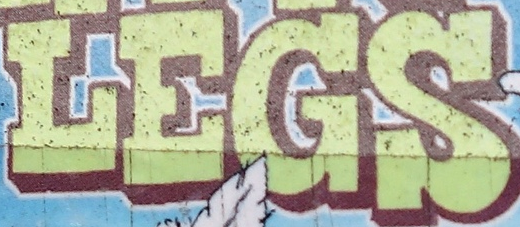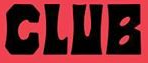Read the text content from these images in order, separated by a semicolon. LEGS; CLUB 